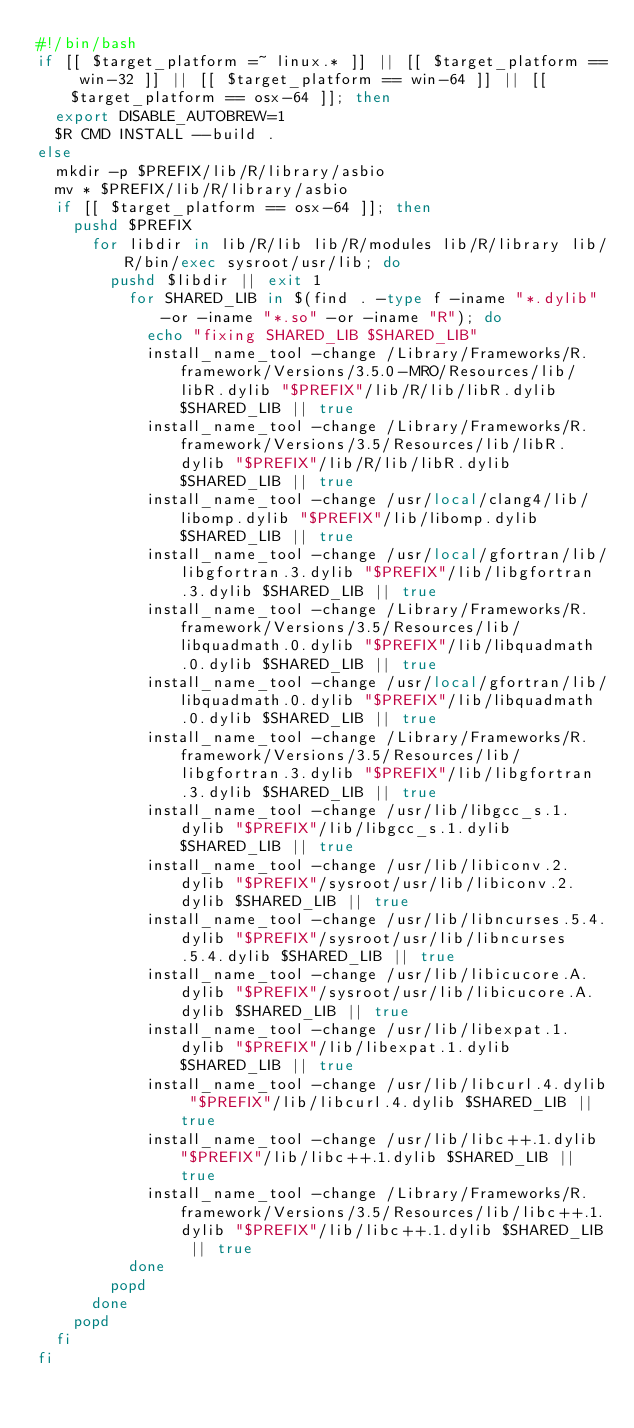<code> <loc_0><loc_0><loc_500><loc_500><_Bash_>#!/bin/bash
if [[ $target_platform =~ linux.* ]] || [[ $target_platform == win-32 ]] || [[ $target_platform == win-64 ]] || [[ $target_platform == osx-64 ]]; then
  export DISABLE_AUTOBREW=1
  $R CMD INSTALL --build .
else
  mkdir -p $PREFIX/lib/R/library/asbio
  mv * $PREFIX/lib/R/library/asbio
  if [[ $target_platform == osx-64 ]]; then
    pushd $PREFIX
      for libdir in lib/R/lib lib/R/modules lib/R/library lib/R/bin/exec sysroot/usr/lib; do
        pushd $libdir || exit 1
          for SHARED_LIB in $(find . -type f -iname "*.dylib" -or -iname "*.so" -or -iname "R"); do
            echo "fixing SHARED_LIB $SHARED_LIB"
            install_name_tool -change /Library/Frameworks/R.framework/Versions/3.5.0-MRO/Resources/lib/libR.dylib "$PREFIX"/lib/R/lib/libR.dylib $SHARED_LIB || true
            install_name_tool -change /Library/Frameworks/R.framework/Versions/3.5/Resources/lib/libR.dylib "$PREFIX"/lib/R/lib/libR.dylib $SHARED_LIB || true
            install_name_tool -change /usr/local/clang4/lib/libomp.dylib "$PREFIX"/lib/libomp.dylib $SHARED_LIB || true
            install_name_tool -change /usr/local/gfortran/lib/libgfortran.3.dylib "$PREFIX"/lib/libgfortran.3.dylib $SHARED_LIB || true
            install_name_tool -change /Library/Frameworks/R.framework/Versions/3.5/Resources/lib/libquadmath.0.dylib "$PREFIX"/lib/libquadmath.0.dylib $SHARED_LIB || true
            install_name_tool -change /usr/local/gfortran/lib/libquadmath.0.dylib "$PREFIX"/lib/libquadmath.0.dylib $SHARED_LIB || true
            install_name_tool -change /Library/Frameworks/R.framework/Versions/3.5/Resources/lib/libgfortran.3.dylib "$PREFIX"/lib/libgfortran.3.dylib $SHARED_LIB || true
            install_name_tool -change /usr/lib/libgcc_s.1.dylib "$PREFIX"/lib/libgcc_s.1.dylib $SHARED_LIB || true
            install_name_tool -change /usr/lib/libiconv.2.dylib "$PREFIX"/sysroot/usr/lib/libiconv.2.dylib $SHARED_LIB || true
            install_name_tool -change /usr/lib/libncurses.5.4.dylib "$PREFIX"/sysroot/usr/lib/libncurses.5.4.dylib $SHARED_LIB || true
            install_name_tool -change /usr/lib/libicucore.A.dylib "$PREFIX"/sysroot/usr/lib/libicucore.A.dylib $SHARED_LIB || true
            install_name_tool -change /usr/lib/libexpat.1.dylib "$PREFIX"/lib/libexpat.1.dylib $SHARED_LIB || true
            install_name_tool -change /usr/lib/libcurl.4.dylib "$PREFIX"/lib/libcurl.4.dylib $SHARED_LIB || true
            install_name_tool -change /usr/lib/libc++.1.dylib "$PREFIX"/lib/libc++.1.dylib $SHARED_LIB || true
            install_name_tool -change /Library/Frameworks/R.framework/Versions/3.5/Resources/lib/libc++.1.dylib "$PREFIX"/lib/libc++.1.dylib $SHARED_LIB || true
          done
        popd
      done
    popd
  fi
fi
</code> 